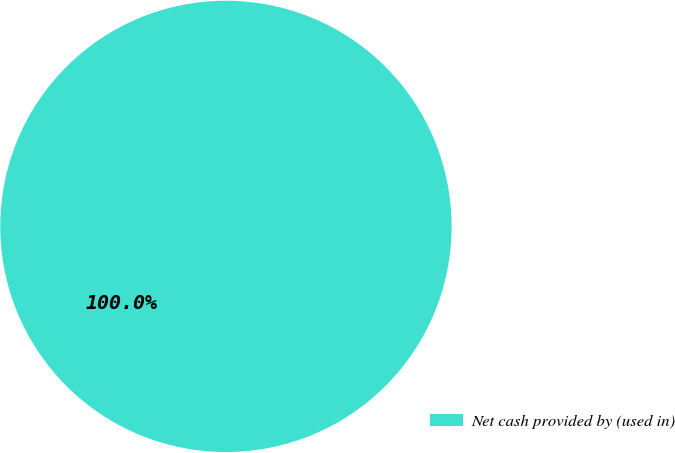<chart> <loc_0><loc_0><loc_500><loc_500><pie_chart><fcel>Net cash provided by (used in)<nl><fcel>100.0%<nl></chart> 